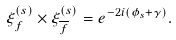<formula> <loc_0><loc_0><loc_500><loc_500>\xi _ { f } ^ { ( s ) } \times \xi _ { \overline { f } } ^ { ( s ) } = e ^ { - 2 i ( \phi _ { s } + \gamma ) } .</formula> 